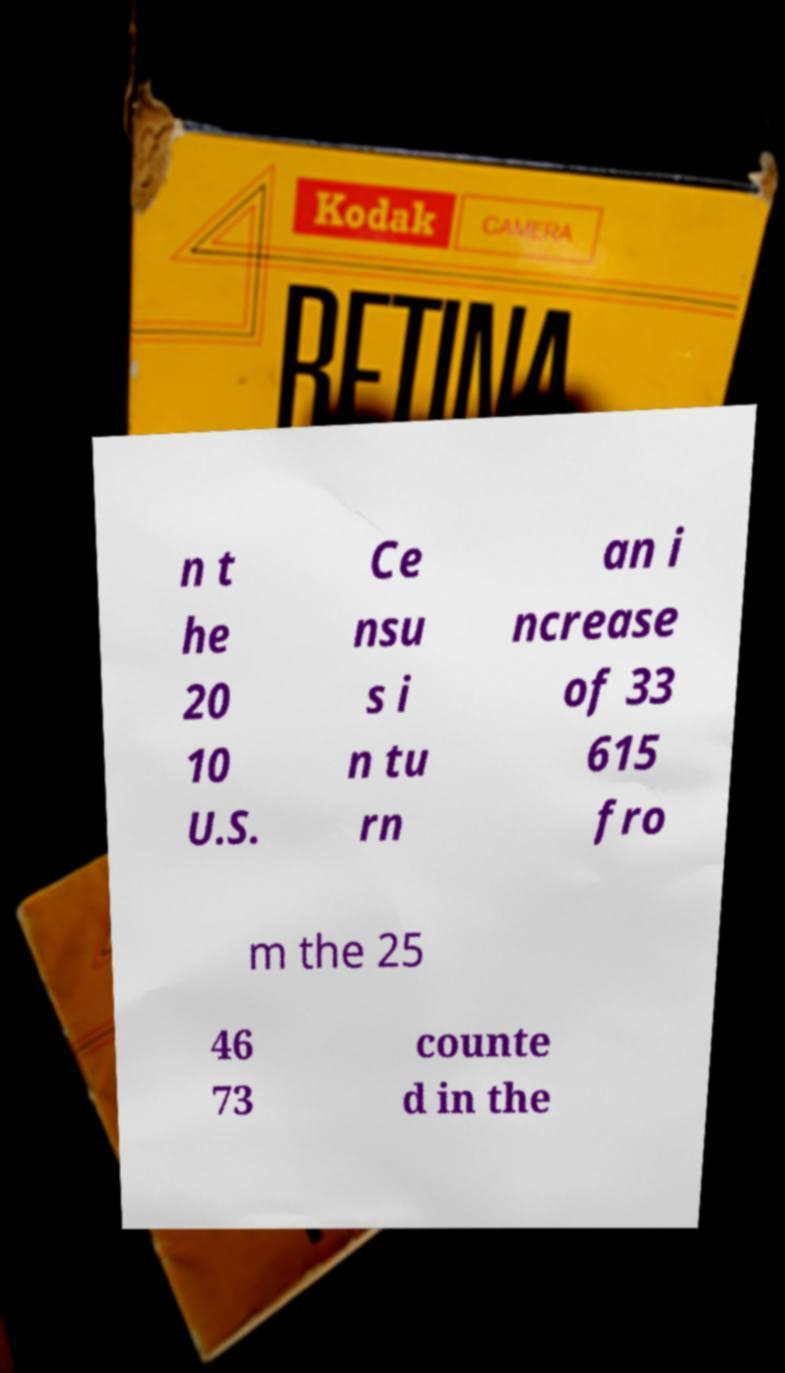What messages or text are displayed in this image? I need them in a readable, typed format. n t he 20 10 U.S. Ce nsu s i n tu rn an i ncrease of 33 615 fro m the 25 46 73 counte d in the 